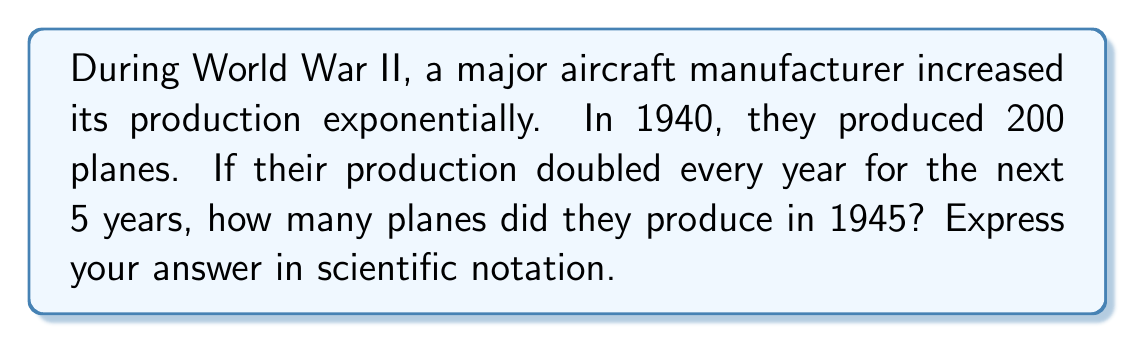Could you help me with this problem? Let's approach this step-by-step:

1) We start with 200 planes in 1940.
2) The production doubles every year for 5 years (1941-1945).
3) This can be represented as an exponential function:

   $$ P = 200 \cdot 2^n $$

   Where $P$ is the number of planes and $n$ is the number of years since 1940.

4) We want to find the production in 1945, which is 5 years after 1940.
   So, we substitute $n = 5$:

   $$ P = 200 \cdot 2^5 $$

5) Let's calculate $2^5$:
   $$ 2^5 = 2 \cdot 2 \cdot 2 \cdot 2 \cdot 2 = 32 $$

6) Now we can calculate P:
   $$ P = 200 \cdot 32 = 6,400 $$

7) To express this in scientific notation, we move the decimal point 3 places to the left:
   $$ 6,400 = 6.4 \cdot 10^3 $$

Therefore, in 1945, the manufacturer produced $6.4 \cdot 10^3$ planes.
Answer: $6.4 \cdot 10^3$ planes 